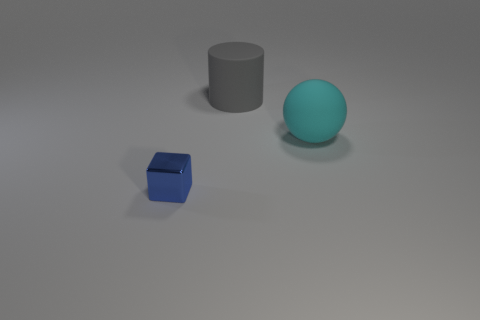Are there any other things that are the same size as the blue thing?
Offer a terse response. No. What number of small gray metal balls are there?
Ensure brevity in your answer.  0. There is a thing that is behind the ball that is in front of the object that is behind the big sphere; what is its material?
Make the answer very short. Rubber. Is there a big sphere made of the same material as the big gray cylinder?
Keep it short and to the point. Yes. Does the gray thing have the same material as the large ball?
Your answer should be very brief. Yes. What number of cylinders are tiny brown objects or rubber things?
Provide a succinct answer. 1. There is a big object that is the same material as the large gray cylinder; what color is it?
Keep it short and to the point. Cyan. Is the number of tiny metallic objects less than the number of gray cubes?
Your answer should be very brief. No. There is a big thing that is on the left side of the big cyan rubber object; does it have the same shape as the object in front of the sphere?
Offer a terse response. No. How many things are large things or metallic blocks?
Your response must be concise. 3. 